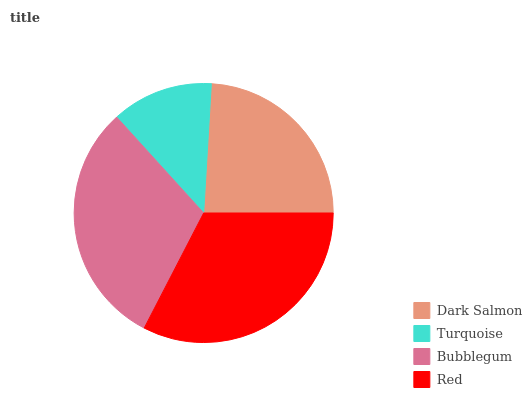Is Turquoise the minimum?
Answer yes or no. Yes. Is Red the maximum?
Answer yes or no. Yes. Is Bubblegum the minimum?
Answer yes or no. No. Is Bubblegum the maximum?
Answer yes or no. No. Is Bubblegum greater than Turquoise?
Answer yes or no. Yes. Is Turquoise less than Bubblegum?
Answer yes or no. Yes. Is Turquoise greater than Bubblegum?
Answer yes or no. No. Is Bubblegum less than Turquoise?
Answer yes or no. No. Is Bubblegum the high median?
Answer yes or no. Yes. Is Dark Salmon the low median?
Answer yes or no. Yes. Is Turquoise the high median?
Answer yes or no. No. Is Red the low median?
Answer yes or no. No. 